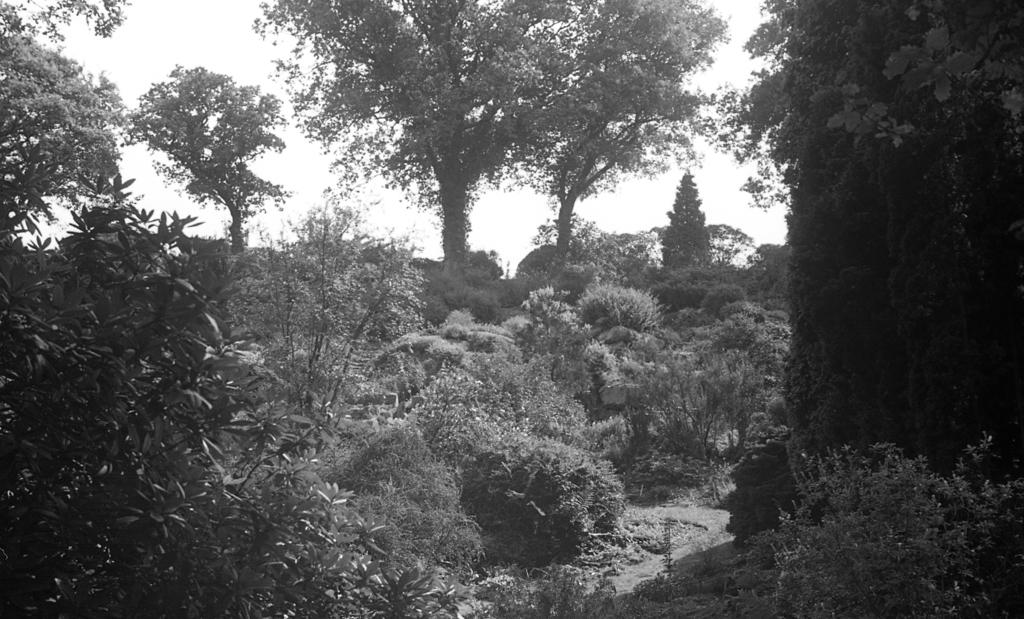What is the color scheme of the image? The image is black and white. What type of environment is depicted in the image? The image appears to depict a forest. What are the main features of the forest? There are many trees and plants in the image. What is visible at the top of the image? The sky is visible at the top of the image. How does the image provide comfort to the viewer? The image does not provide comfort to the viewer, as it is a visual representation and does not have the ability to provide comfort. 